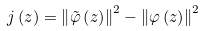<formula> <loc_0><loc_0><loc_500><loc_500>j \left ( z \right ) = \left \| \tilde { \varphi } \left ( z \right ) \right \| ^ { 2 } - \left \| \varphi \left ( z \right ) \right \| ^ { 2 }</formula> 